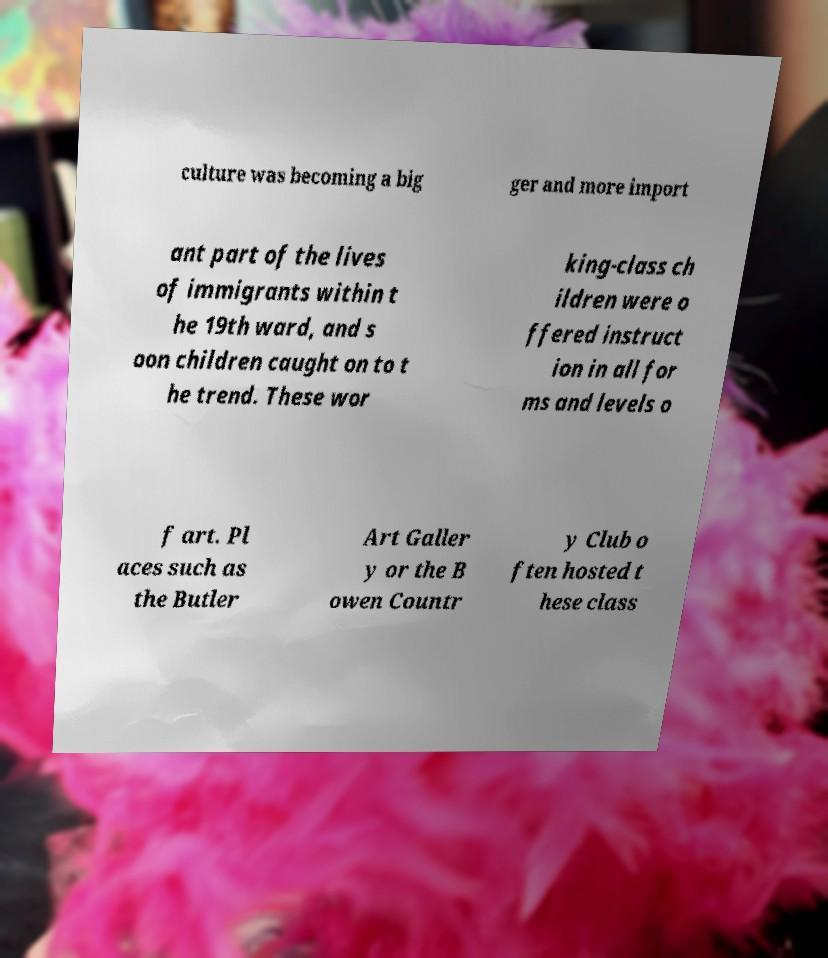Can you read and provide the text displayed in the image?This photo seems to have some interesting text. Can you extract and type it out for me? culture was becoming a big ger and more import ant part of the lives of immigrants within t he 19th ward, and s oon children caught on to t he trend. These wor king-class ch ildren were o ffered instruct ion in all for ms and levels o f art. Pl aces such as the Butler Art Galler y or the B owen Countr y Club o ften hosted t hese class 